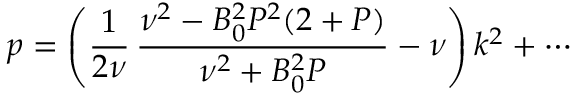Convert formula to latex. <formula><loc_0><loc_0><loc_500><loc_500>p = \left ( \frac { 1 } { 2 \nu } \, \frac { \nu ^ { 2 } - B _ { 0 } ^ { 2 } P ^ { 2 } ( 2 + P ) } { \nu ^ { 2 } + B _ { 0 } ^ { 2 } P } - \nu \right ) k ^ { 2 } + \cdots</formula> 